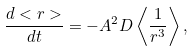Convert formula to latex. <formula><loc_0><loc_0><loc_500><loc_500>\frac { d < r > } { d t } = - A ^ { 2 } D \left < \frac { 1 } { r ^ { 3 } } \right > ,</formula> 